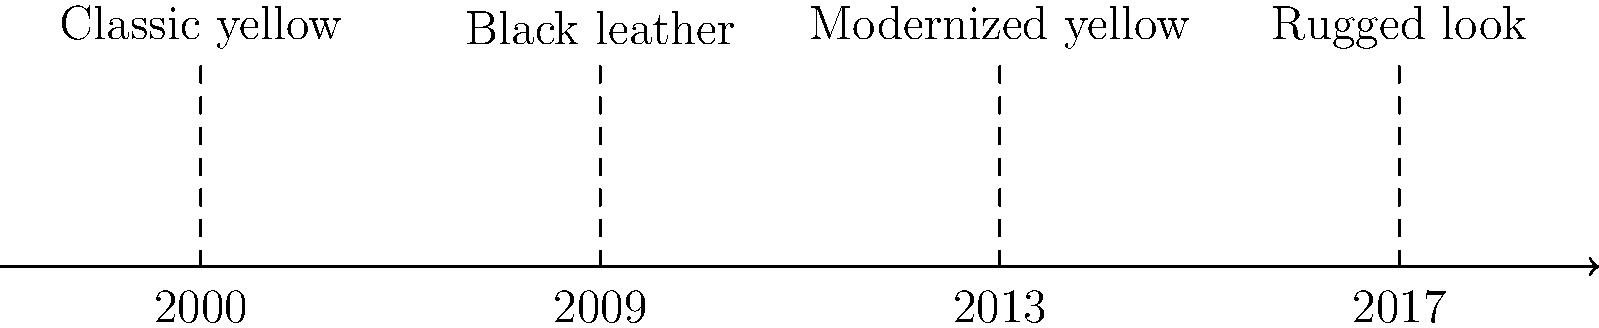Based on the timeline of Wolverine's costume evolution in films, which design marked a significant departure from the comic book origins and why might this choice have been made? To answer this question, let's analyze the timeline of Wolverine's costume evolution:

1. 2000: The "Classic yellow" costume, which is closest to the comic book origins.
2. 2009: The "Black leather" costume, which marks a significant departure from the comic book look.
3. 2013: The "Modernized yellow" costume, which attempts to blend comic and film aesthetics.
4. 2017: The "Rugged look," which focuses on a more realistic, worn appearance.

The "Black leather" costume from 2009 represents the most significant departure from Wolverine's comic book origins. This design choice was likely made for several reasons:

1. Realism: The black leather costume appeared more practical and realistic for a modern action film.
2. Cohesion with the X-Men team: It aligned Wolverine's look with the rest of the X-Men, who also wore black leather uniforms in the films.
3. Audience appeal: The filmmakers may have believed that a more subdued, "cooler" look would resonate better with general audiences unfamiliar with the comic book aesthetics.
4. Distancing from campy superhero imagery: The black costume helped separate the film version from potentially "silly" or outdated comic book visuals.

This shift in costume design reflects a broader trend in early 2000s superhero films to ground fantastical characters in a more realistic aesthetic.
Answer: The 2009 black leather costume, chosen for realism and audience appeal. 